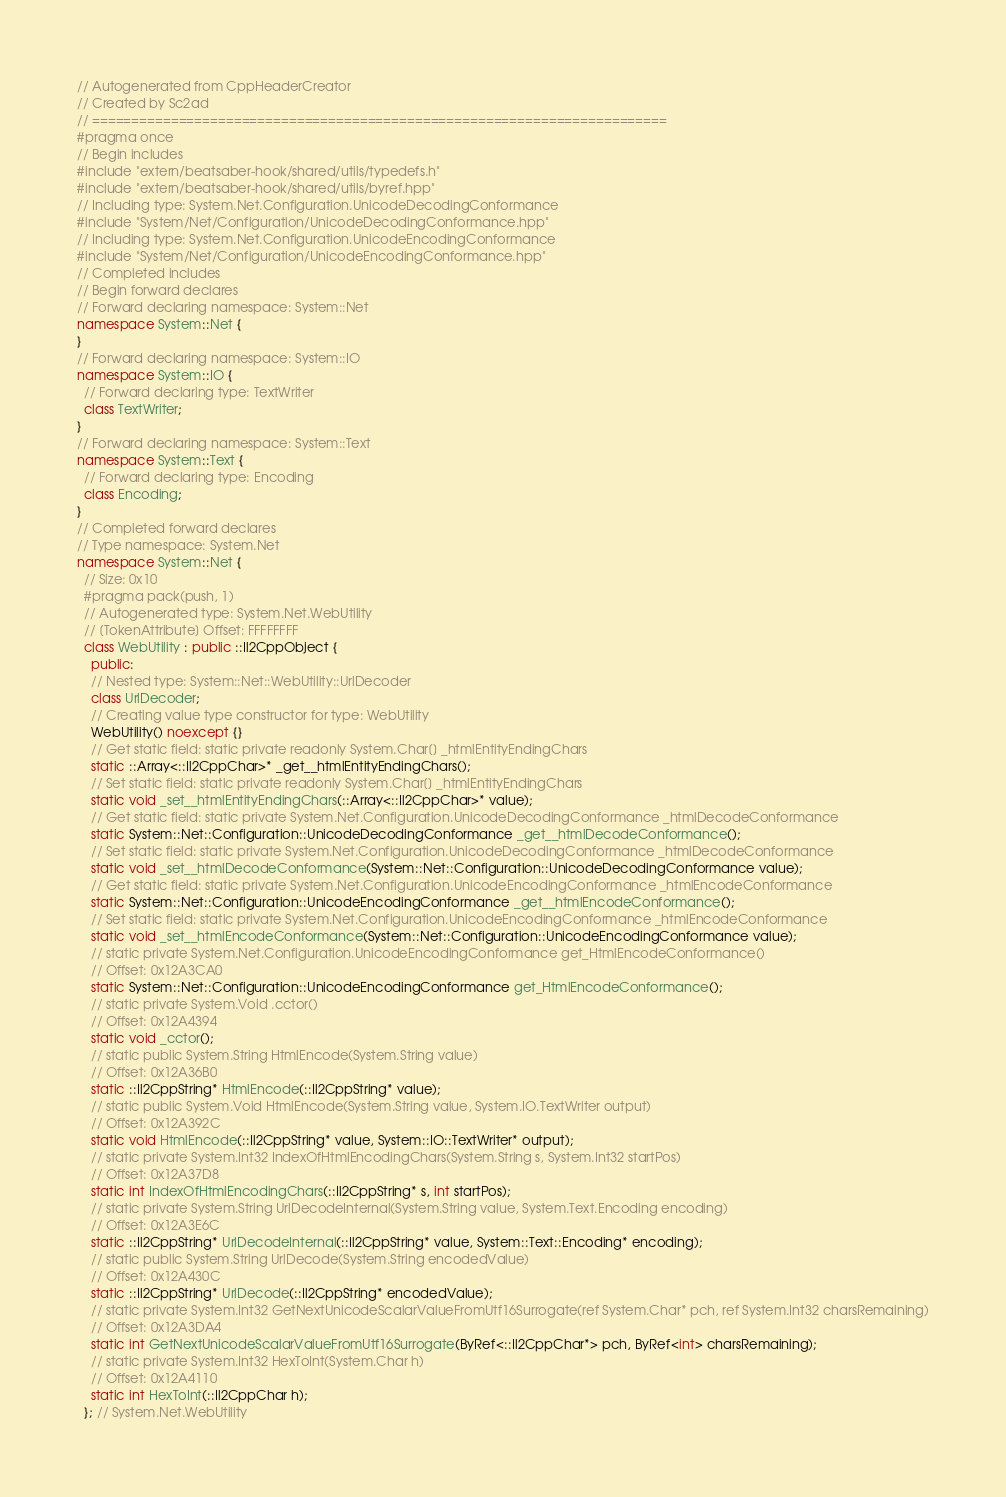Convert code to text. <code><loc_0><loc_0><loc_500><loc_500><_C++_>// Autogenerated from CppHeaderCreator
// Created by Sc2ad
// =========================================================================
#pragma once
// Begin includes
#include "extern/beatsaber-hook/shared/utils/typedefs.h"
#include "extern/beatsaber-hook/shared/utils/byref.hpp"
// Including type: System.Net.Configuration.UnicodeDecodingConformance
#include "System/Net/Configuration/UnicodeDecodingConformance.hpp"
// Including type: System.Net.Configuration.UnicodeEncodingConformance
#include "System/Net/Configuration/UnicodeEncodingConformance.hpp"
// Completed includes
// Begin forward declares
// Forward declaring namespace: System::Net
namespace System::Net {
}
// Forward declaring namespace: System::IO
namespace System::IO {
  // Forward declaring type: TextWriter
  class TextWriter;
}
// Forward declaring namespace: System::Text
namespace System::Text {
  // Forward declaring type: Encoding
  class Encoding;
}
// Completed forward declares
// Type namespace: System.Net
namespace System::Net {
  // Size: 0x10
  #pragma pack(push, 1)
  // Autogenerated type: System.Net.WebUtility
  // [TokenAttribute] Offset: FFFFFFFF
  class WebUtility : public ::Il2CppObject {
    public:
    // Nested type: System::Net::WebUtility::UrlDecoder
    class UrlDecoder;
    // Creating value type constructor for type: WebUtility
    WebUtility() noexcept {}
    // Get static field: static private readonly System.Char[] _htmlEntityEndingChars
    static ::Array<::Il2CppChar>* _get__htmlEntityEndingChars();
    // Set static field: static private readonly System.Char[] _htmlEntityEndingChars
    static void _set__htmlEntityEndingChars(::Array<::Il2CppChar>* value);
    // Get static field: static private System.Net.Configuration.UnicodeDecodingConformance _htmlDecodeConformance
    static System::Net::Configuration::UnicodeDecodingConformance _get__htmlDecodeConformance();
    // Set static field: static private System.Net.Configuration.UnicodeDecodingConformance _htmlDecodeConformance
    static void _set__htmlDecodeConformance(System::Net::Configuration::UnicodeDecodingConformance value);
    // Get static field: static private System.Net.Configuration.UnicodeEncodingConformance _htmlEncodeConformance
    static System::Net::Configuration::UnicodeEncodingConformance _get__htmlEncodeConformance();
    // Set static field: static private System.Net.Configuration.UnicodeEncodingConformance _htmlEncodeConformance
    static void _set__htmlEncodeConformance(System::Net::Configuration::UnicodeEncodingConformance value);
    // static private System.Net.Configuration.UnicodeEncodingConformance get_HtmlEncodeConformance()
    // Offset: 0x12A3CA0
    static System::Net::Configuration::UnicodeEncodingConformance get_HtmlEncodeConformance();
    // static private System.Void .cctor()
    // Offset: 0x12A4394
    static void _cctor();
    // static public System.String HtmlEncode(System.String value)
    // Offset: 0x12A36B0
    static ::Il2CppString* HtmlEncode(::Il2CppString* value);
    // static public System.Void HtmlEncode(System.String value, System.IO.TextWriter output)
    // Offset: 0x12A392C
    static void HtmlEncode(::Il2CppString* value, System::IO::TextWriter* output);
    // static private System.Int32 IndexOfHtmlEncodingChars(System.String s, System.Int32 startPos)
    // Offset: 0x12A37D8
    static int IndexOfHtmlEncodingChars(::Il2CppString* s, int startPos);
    // static private System.String UrlDecodeInternal(System.String value, System.Text.Encoding encoding)
    // Offset: 0x12A3E6C
    static ::Il2CppString* UrlDecodeInternal(::Il2CppString* value, System::Text::Encoding* encoding);
    // static public System.String UrlDecode(System.String encodedValue)
    // Offset: 0x12A430C
    static ::Il2CppString* UrlDecode(::Il2CppString* encodedValue);
    // static private System.Int32 GetNextUnicodeScalarValueFromUtf16Surrogate(ref System.Char* pch, ref System.Int32 charsRemaining)
    // Offset: 0x12A3DA4
    static int GetNextUnicodeScalarValueFromUtf16Surrogate(ByRef<::Il2CppChar*> pch, ByRef<int> charsRemaining);
    // static private System.Int32 HexToInt(System.Char h)
    // Offset: 0x12A4110
    static int HexToInt(::Il2CppChar h);
  }; // System.Net.WebUtility</code> 